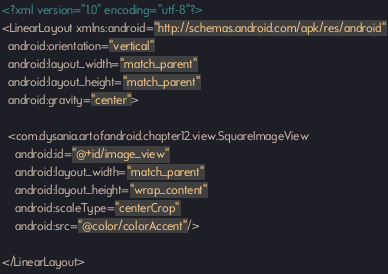<code> <loc_0><loc_0><loc_500><loc_500><_XML_><?xml version="1.0" encoding="utf-8"?>
<LinearLayout xmlns:android="http://schemas.android.com/apk/res/android"
  android:orientation="vertical"
  android:layout_width="match_parent"
  android:layout_height="match_parent"
  android:gravity="center">

  <com.dysania.artofandroid.chapter12.view.SquareImageView
    android:id="@+id/image_view"
    android:layout_width="match_parent"
    android:layout_height="wrap_content"
    android:scaleType="centerCrop"
    android:src="@color/colorAccent"/>

</LinearLayout></code> 